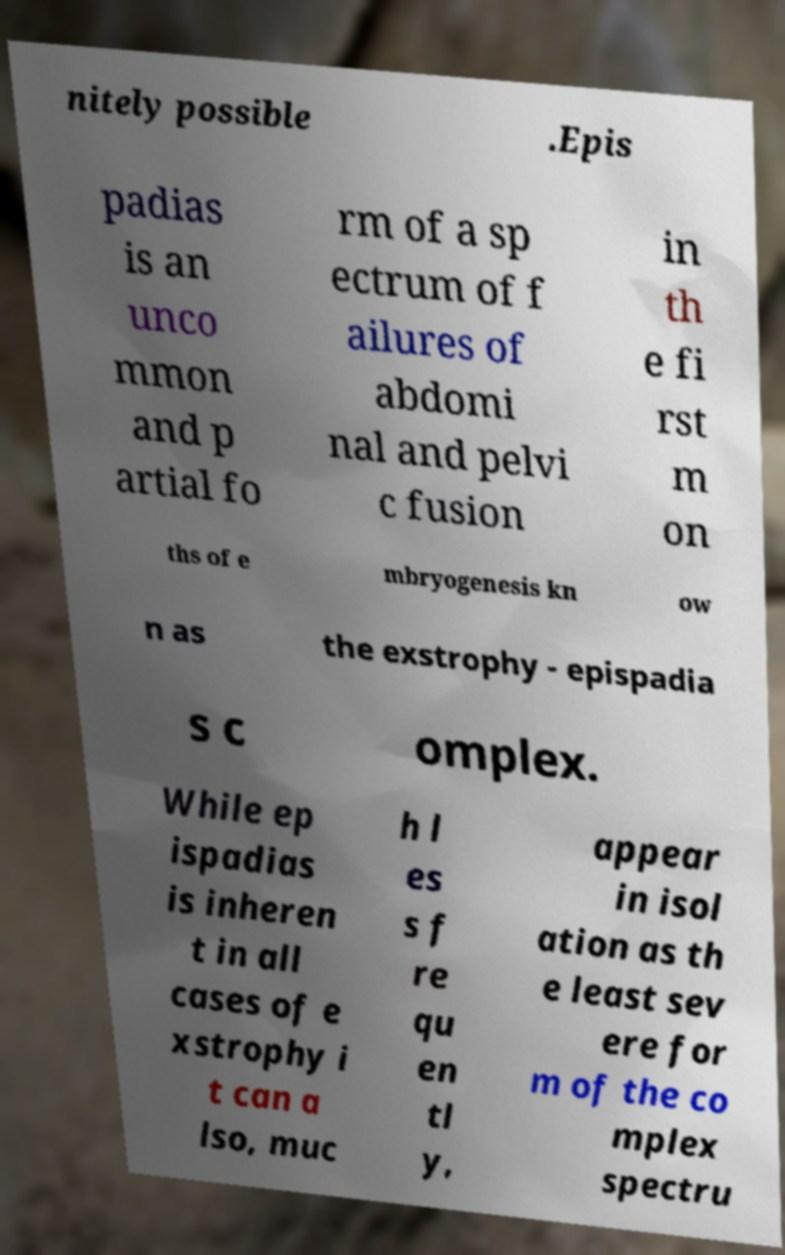Please read and relay the text visible in this image. What does it say? nitely possible .Epis padias is an unco mmon and p artial fo rm of a sp ectrum of f ailures of abdomi nal and pelvi c fusion in th e fi rst m on ths of e mbryogenesis kn ow n as the exstrophy - epispadia s c omplex. While ep ispadias is inheren t in all cases of e xstrophy i t can a lso, muc h l es s f re qu en tl y, appear in isol ation as th e least sev ere for m of the co mplex spectru 